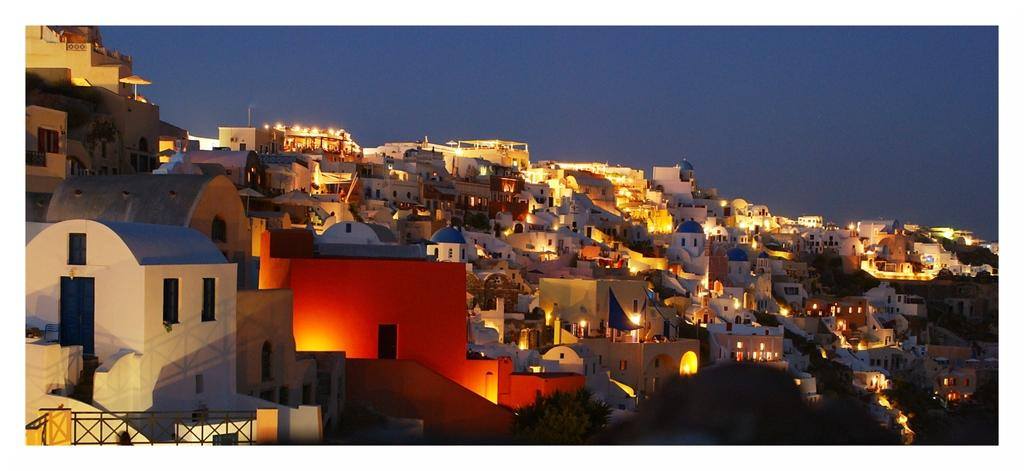What is located at the bottom of the image? There are buildings and trees at the bottom of the image. What else can be seen at the bottom of the image? Lights are arranged at the bottom of the image. What is visible in the background of the image? There are clouds and the sky is blue in the background of the image. Can you tell me how many geese are in the garden in the image? There is no garden or geese present in the image. Is there a horse grazing in the background of the image? There is no horse present in the image; only clouds and a blue sky are visible in the background. 